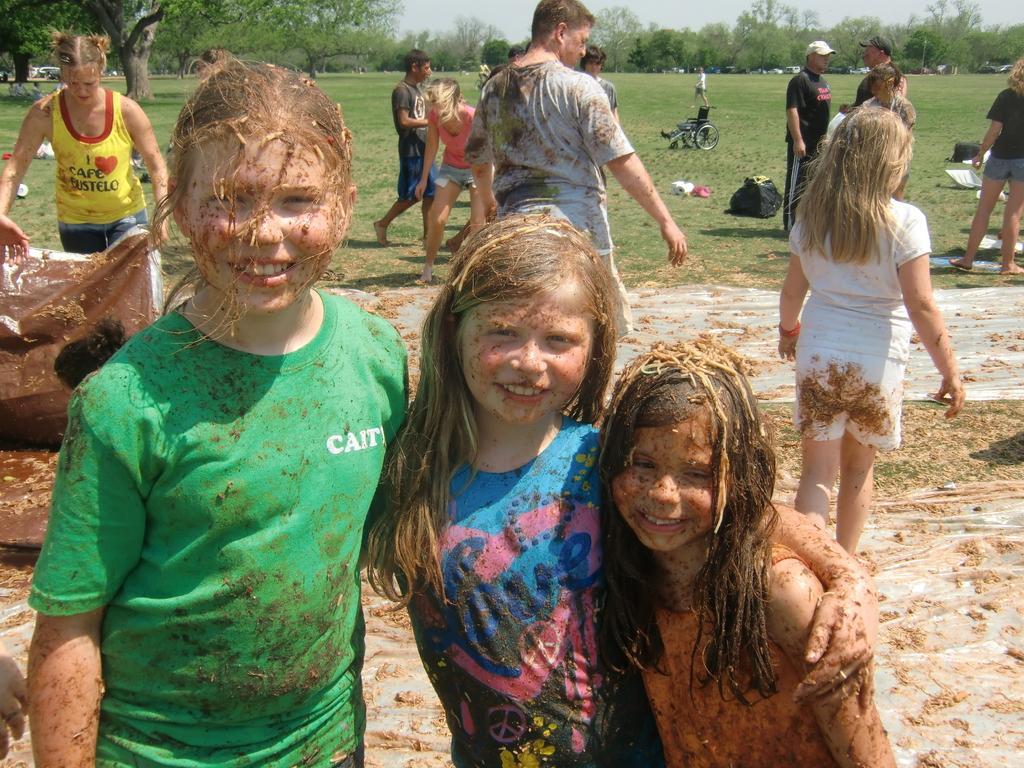Could you give a brief overview of what you see in this image? In this picture we can see some people are standing, at the bottom there is mud, we can see a wheel chair, a bag, grass, trees and vehicles in the background, there is the sky at the top of the picture. 